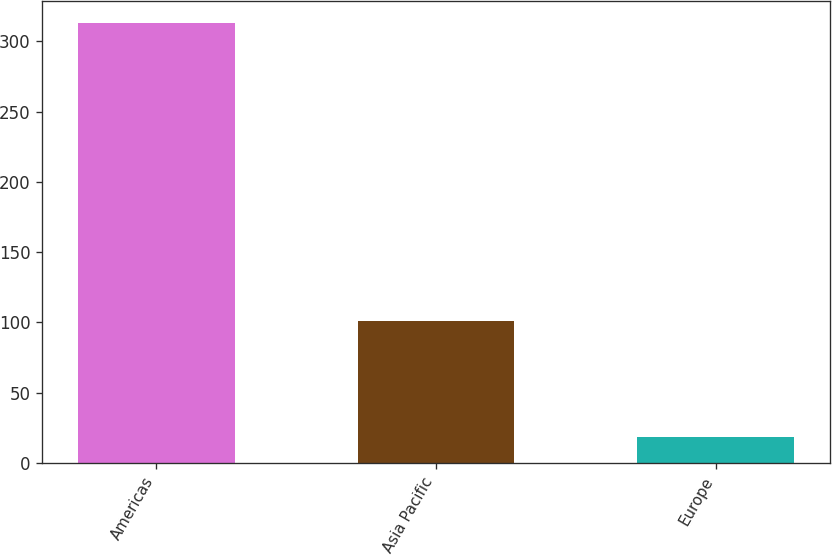Convert chart. <chart><loc_0><loc_0><loc_500><loc_500><bar_chart><fcel>Americas<fcel>Asia Pacific<fcel>Europe<nl><fcel>313.4<fcel>100.9<fcel>18.5<nl></chart> 